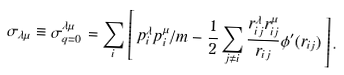<formula> <loc_0><loc_0><loc_500><loc_500>\sigma _ { \lambda \mu } \equiv \sigma _ { { q } = { 0 } } ^ { \lambda \mu } = \sum _ { i } \left [ \, p _ { i } ^ { \lambda } p _ { i } ^ { \mu } / m - \frac { 1 } { 2 } \sum _ { j \ne i } \frac { r _ { i j } ^ { \lambda } r _ { i j } ^ { \mu } } { r _ { i j } } \phi ^ { \prime } ( r _ { i j } ) \, \right ] .</formula> 